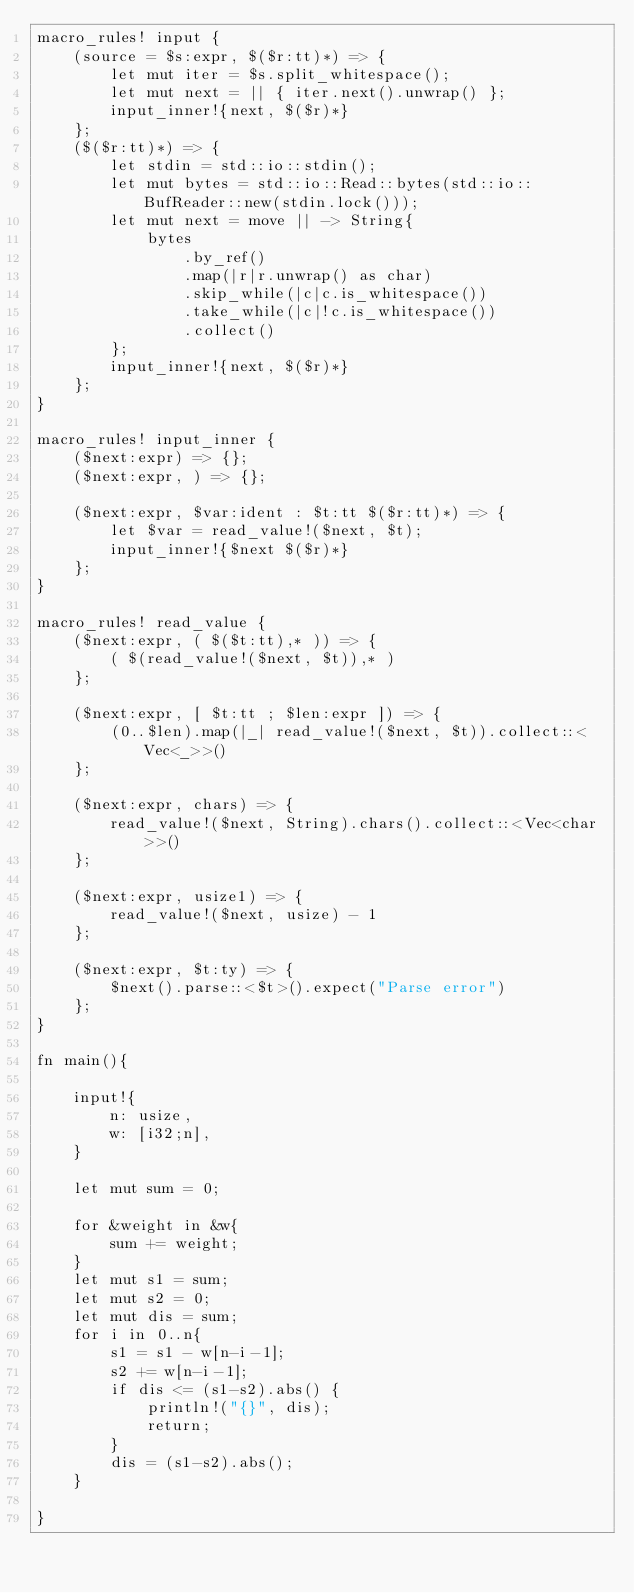Convert code to text. <code><loc_0><loc_0><loc_500><loc_500><_Rust_>macro_rules! input {
    (source = $s:expr, $($r:tt)*) => {
        let mut iter = $s.split_whitespace();
        let mut next = || { iter.next().unwrap() };
        input_inner!{next, $($r)*}
    };
    ($($r:tt)*) => {
        let stdin = std::io::stdin();
        let mut bytes = std::io::Read::bytes(std::io::BufReader::new(stdin.lock()));
        let mut next = move || -> String{
            bytes
                .by_ref()
                .map(|r|r.unwrap() as char)
                .skip_while(|c|c.is_whitespace())
                .take_while(|c|!c.is_whitespace())
                .collect()
        };
        input_inner!{next, $($r)*}
    };
}

macro_rules! input_inner {
    ($next:expr) => {};
    ($next:expr, ) => {};

    ($next:expr, $var:ident : $t:tt $($r:tt)*) => {
        let $var = read_value!($next, $t);
        input_inner!{$next $($r)*}
    };
}

macro_rules! read_value {
    ($next:expr, ( $($t:tt),* )) => {
        ( $(read_value!($next, $t)),* )
    };

    ($next:expr, [ $t:tt ; $len:expr ]) => {
        (0..$len).map(|_| read_value!($next, $t)).collect::<Vec<_>>()
    };

    ($next:expr, chars) => {
        read_value!($next, String).chars().collect::<Vec<char>>()
    };

    ($next:expr, usize1) => {
        read_value!($next, usize) - 1
    };

    ($next:expr, $t:ty) => {
        $next().parse::<$t>().expect("Parse error")
    };
}

fn main(){

    input!{
        n: usize,
        w: [i32;n],
    }

    let mut sum = 0;
    
    for &weight in &w{
        sum += weight;
    }
    let mut s1 = sum;
    let mut s2 = 0;
    let mut dis = sum;
    for i in 0..n{
        s1 = s1 - w[n-i-1];
        s2 += w[n-i-1];
        if dis <= (s1-s2).abs() {
            println!("{}", dis);
            return;
        }
        dis = (s1-s2).abs();
    }

}</code> 